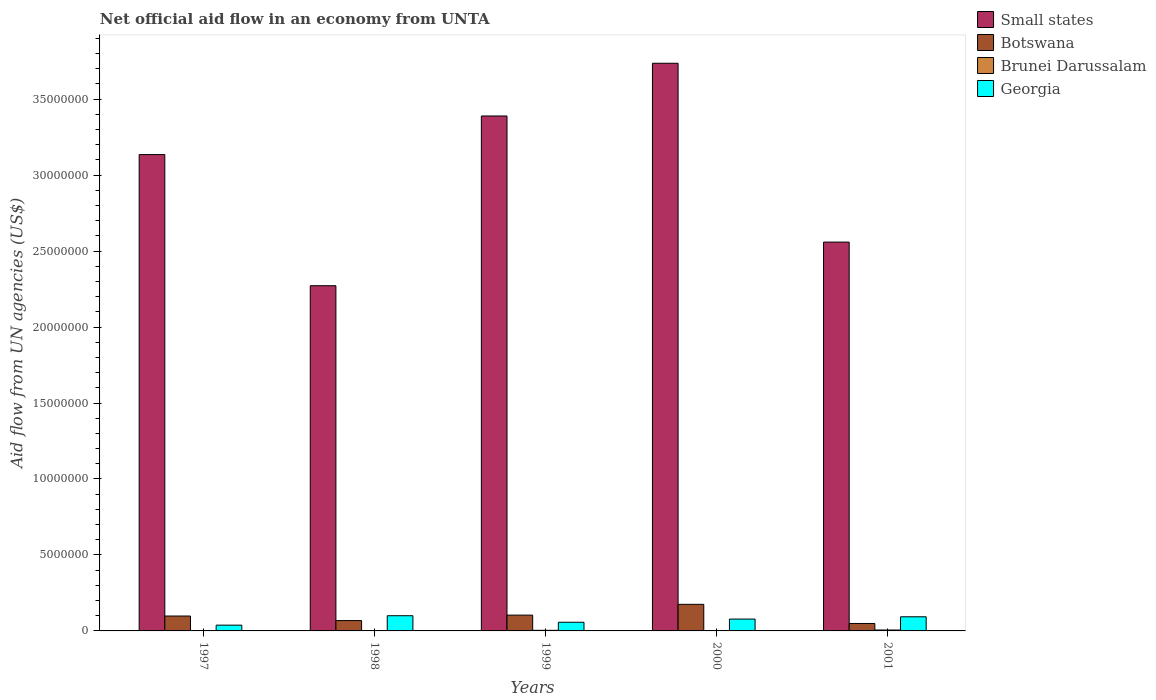Are the number of bars per tick equal to the number of legend labels?
Offer a very short reply. Yes. Are the number of bars on each tick of the X-axis equal?
Your response must be concise. Yes. How many bars are there on the 4th tick from the left?
Your response must be concise. 4. What is the label of the 1st group of bars from the left?
Give a very brief answer. 1997. In how many cases, is the number of bars for a given year not equal to the number of legend labels?
Provide a short and direct response. 0. What is the net official aid flow in Georgia in 1998?
Ensure brevity in your answer.  1.00e+06. Across all years, what is the maximum net official aid flow in Brunei Darussalam?
Ensure brevity in your answer.  6.00e+04. Across all years, what is the minimum net official aid flow in Botswana?
Offer a very short reply. 4.90e+05. In which year was the net official aid flow in Botswana minimum?
Ensure brevity in your answer.  2001. What is the difference between the net official aid flow in Brunei Darussalam in 1997 and that in 2001?
Your answer should be very brief. -4.00e+04. What is the difference between the net official aid flow in Small states in 2000 and the net official aid flow in Botswana in 1997?
Make the answer very short. 3.64e+07. What is the average net official aid flow in Brunei Darussalam per year?
Offer a very short reply. 2.80e+04. In the year 2000, what is the difference between the net official aid flow in Small states and net official aid flow in Botswana?
Provide a short and direct response. 3.56e+07. What is the ratio of the net official aid flow in Small states in 1997 to that in 2000?
Offer a very short reply. 0.84. What is the difference between the highest and the second highest net official aid flow in Small states?
Your answer should be compact. 3.47e+06. What is the difference between the highest and the lowest net official aid flow in Small states?
Your answer should be very brief. 1.46e+07. In how many years, is the net official aid flow in Brunei Darussalam greater than the average net official aid flow in Brunei Darussalam taken over all years?
Provide a short and direct response. 2. Is the sum of the net official aid flow in Botswana in 1999 and 2001 greater than the maximum net official aid flow in Small states across all years?
Ensure brevity in your answer.  No. Is it the case that in every year, the sum of the net official aid flow in Georgia and net official aid flow in Botswana is greater than the sum of net official aid flow in Small states and net official aid flow in Brunei Darussalam?
Your answer should be compact. No. What does the 1st bar from the left in 2000 represents?
Offer a very short reply. Small states. What does the 3rd bar from the right in 1997 represents?
Your response must be concise. Botswana. How many bars are there?
Offer a terse response. 20. Are all the bars in the graph horizontal?
Provide a short and direct response. No. Does the graph contain grids?
Keep it short and to the point. No. Where does the legend appear in the graph?
Keep it short and to the point. Top right. What is the title of the graph?
Offer a terse response. Net official aid flow in an economy from UNTA. What is the label or title of the X-axis?
Offer a terse response. Years. What is the label or title of the Y-axis?
Your answer should be very brief. Aid flow from UN agencies (US$). What is the Aid flow from UN agencies (US$) in Small states in 1997?
Your answer should be compact. 3.14e+07. What is the Aid flow from UN agencies (US$) of Botswana in 1997?
Provide a short and direct response. 9.80e+05. What is the Aid flow from UN agencies (US$) of Brunei Darussalam in 1997?
Give a very brief answer. 2.00e+04. What is the Aid flow from UN agencies (US$) in Small states in 1998?
Provide a succinct answer. 2.27e+07. What is the Aid flow from UN agencies (US$) of Botswana in 1998?
Your answer should be compact. 6.80e+05. What is the Aid flow from UN agencies (US$) of Brunei Darussalam in 1998?
Offer a very short reply. 10000. What is the Aid flow from UN agencies (US$) in Georgia in 1998?
Offer a very short reply. 1.00e+06. What is the Aid flow from UN agencies (US$) in Small states in 1999?
Keep it short and to the point. 3.39e+07. What is the Aid flow from UN agencies (US$) of Botswana in 1999?
Give a very brief answer. 1.04e+06. What is the Aid flow from UN agencies (US$) in Brunei Darussalam in 1999?
Make the answer very short. 4.00e+04. What is the Aid flow from UN agencies (US$) in Georgia in 1999?
Your answer should be very brief. 5.70e+05. What is the Aid flow from UN agencies (US$) of Small states in 2000?
Offer a very short reply. 3.74e+07. What is the Aid flow from UN agencies (US$) of Botswana in 2000?
Provide a short and direct response. 1.75e+06. What is the Aid flow from UN agencies (US$) of Georgia in 2000?
Provide a short and direct response. 7.80e+05. What is the Aid flow from UN agencies (US$) of Small states in 2001?
Your response must be concise. 2.56e+07. What is the Aid flow from UN agencies (US$) in Brunei Darussalam in 2001?
Give a very brief answer. 6.00e+04. What is the Aid flow from UN agencies (US$) of Georgia in 2001?
Your response must be concise. 9.30e+05. Across all years, what is the maximum Aid flow from UN agencies (US$) in Small states?
Ensure brevity in your answer.  3.74e+07. Across all years, what is the maximum Aid flow from UN agencies (US$) in Botswana?
Provide a short and direct response. 1.75e+06. Across all years, what is the maximum Aid flow from UN agencies (US$) of Brunei Darussalam?
Keep it short and to the point. 6.00e+04. Across all years, what is the maximum Aid flow from UN agencies (US$) in Georgia?
Keep it short and to the point. 1.00e+06. Across all years, what is the minimum Aid flow from UN agencies (US$) of Small states?
Offer a terse response. 2.27e+07. Across all years, what is the minimum Aid flow from UN agencies (US$) of Botswana?
Your answer should be compact. 4.90e+05. Across all years, what is the minimum Aid flow from UN agencies (US$) of Georgia?
Your answer should be very brief. 3.80e+05. What is the total Aid flow from UN agencies (US$) in Small states in the graph?
Your response must be concise. 1.51e+08. What is the total Aid flow from UN agencies (US$) in Botswana in the graph?
Give a very brief answer. 4.94e+06. What is the total Aid flow from UN agencies (US$) in Brunei Darussalam in the graph?
Offer a very short reply. 1.40e+05. What is the total Aid flow from UN agencies (US$) in Georgia in the graph?
Provide a short and direct response. 3.66e+06. What is the difference between the Aid flow from UN agencies (US$) of Small states in 1997 and that in 1998?
Make the answer very short. 8.63e+06. What is the difference between the Aid flow from UN agencies (US$) of Botswana in 1997 and that in 1998?
Your answer should be very brief. 3.00e+05. What is the difference between the Aid flow from UN agencies (US$) in Brunei Darussalam in 1997 and that in 1998?
Offer a very short reply. 10000. What is the difference between the Aid flow from UN agencies (US$) of Georgia in 1997 and that in 1998?
Offer a terse response. -6.20e+05. What is the difference between the Aid flow from UN agencies (US$) of Small states in 1997 and that in 1999?
Make the answer very short. -2.54e+06. What is the difference between the Aid flow from UN agencies (US$) in Georgia in 1997 and that in 1999?
Keep it short and to the point. -1.90e+05. What is the difference between the Aid flow from UN agencies (US$) in Small states in 1997 and that in 2000?
Your response must be concise. -6.01e+06. What is the difference between the Aid flow from UN agencies (US$) of Botswana in 1997 and that in 2000?
Ensure brevity in your answer.  -7.70e+05. What is the difference between the Aid flow from UN agencies (US$) of Georgia in 1997 and that in 2000?
Your answer should be very brief. -4.00e+05. What is the difference between the Aid flow from UN agencies (US$) of Small states in 1997 and that in 2001?
Your answer should be compact. 5.76e+06. What is the difference between the Aid flow from UN agencies (US$) in Georgia in 1997 and that in 2001?
Your response must be concise. -5.50e+05. What is the difference between the Aid flow from UN agencies (US$) in Small states in 1998 and that in 1999?
Your response must be concise. -1.12e+07. What is the difference between the Aid flow from UN agencies (US$) in Botswana in 1998 and that in 1999?
Your answer should be very brief. -3.60e+05. What is the difference between the Aid flow from UN agencies (US$) of Georgia in 1998 and that in 1999?
Provide a succinct answer. 4.30e+05. What is the difference between the Aid flow from UN agencies (US$) of Small states in 1998 and that in 2000?
Offer a very short reply. -1.46e+07. What is the difference between the Aid flow from UN agencies (US$) in Botswana in 1998 and that in 2000?
Provide a succinct answer. -1.07e+06. What is the difference between the Aid flow from UN agencies (US$) of Small states in 1998 and that in 2001?
Give a very brief answer. -2.87e+06. What is the difference between the Aid flow from UN agencies (US$) of Botswana in 1998 and that in 2001?
Your answer should be compact. 1.90e+05. What is the difference between the Aid flow from UN agencies (US$) in Brunei Darussalam in 1998 and that in 2001?
Your response must be concise. -5.00e+04. What is the difference between the Aid flow from UN agencies (US$) in Georgia in 1998 and that in 2001?
Your response must be concise. 7.00e+04. What is the difference between the Aid flow from UN agencies (US$) of Small states in 1999 and that in 2000?
Provide a short and direct response. -3.47e+06. What is the difference between the Aid flow from UN agencies (US$) of Botswana in 1999 and that in 2000?
Keep it short and to the point. -7.10e+05. What is the difference between the Aid flow from UN agencies (US$) of Georgia in 1999 and that in 2000?
Your response must be concise. -2.10e+05. What is the difference between the Aid flow from UN agencies (US$) in Small states in 1999 and that in 2001?
Provide a short and direct response. 8.30e+06. What is the difference between the Aid flow from UN agencies (US$) of Brunei Darussalam in 1999 and that in 2001?
Give a very brief answer. -2.00e+04. What is the difference between the Aid flow from UN agencies (US$) in Georgia in 1999 and that in 2001?
Give a very brief answer. -3.60e+05. What is the difference between the Aid flow from UN agencies (US$) of Small states in 2000 and that in 2001?
Ensure brevity in your answer.  1.18e+07. What is the difference between the Aid flow from UN agencies (US$) in Botswana in 2000 and that in 2001?
Offer a very short reply. 1.26e+06. What is the difference between the Aid flow from UN agencies (US$) in Brunei Darussalam in 2000 and that in 2001?
Offer a very short reply. -5.00e+04. What is the difference between the Aid flow from UN agencies (US$) of Small states in 1997 and the Aid flow from UN agencies (US$) of Botswana in 1998?
Your answer should be very brief. 3.07e+07. What is the difference between the Aid flow from UN agencies (US$) of Small states in 1997 and the Aid flow from UN agencies (US$) of Brunei Darussalam in 1998?
Give a very brief answer. 3.13e+07. What is the difference between the Aid flow from UN agencies (US$) in Small states in 1997 and the Aid flow from UN agencies (US$) in Georgia in 1998?
Provide a short and direct response. 3.04e+07. What is the difference between the Aid flow from UN agencies (US$) in Botswana in 1997 and the Aid flow from UN agencies (US$) in Brunei Darussalam in 1998?
Keep it short and to the point. 9.70e+05. What is the difference between the Aid flow from UN agencies (US$) of Brunei Darussalam in 1997 and the Aid flow from UN agencies (US$) of Georgia in 1998?
Your response must be concise. -9.80e+05. What is the difference between the Aid flow from UN agencies (US$) in Small states in 1997 and the Aid flow from UN agencies (US$) in Botswana in 1999?
Your answer should be very brief. 3.03e+07. What is the difference between the Aid flow from UN agencies (US$) in Small states in 1997 and the Aid flow from UN agencies (US$) in Brunei Darussalam in 1999?
Your response must be concise. 3.13e+07. What is the difference between the Aid flow from UN agencies (US$) in Small states in 1997 and the Aid flow from UN agencies (US$) in Georgia in 1999?
Your answer should be compact. 3.08e+07. What is the difference between the Aid flow from UN agencies (US$) in Botswana in 1997 and the Aid flow from UN agencies (US$) in Brunei Darussalam in 1999?
Keep it short and to the point. 9.40e+05. What is the difference between the Aid flow from UN agencies (US$) in Botswana in 1997 and the Aid flow from UN agencies (US$) in Georgia in 1999?
Provide a short and direct response. 4.10e+05. What is the difference between the Aid flow from UN agencies (US$) of Brunei Darussalam in 1997 and the Aid flow from UN agencies (US$) of Georgia in 1999?
Provide a short and direct response. -5.50e+05. What is the difference between the Aid flow from UN agencies (US$) of Small states in 1997 and the Aid flow from UN agencies (US$) of Botswana in 2000?
Provide a succinct answer. 2.96e+07. What is the difference between the Aid flow from UN agencies (US$) of Small states in 1997 and the Aid flow from UN agencies (US$) of Brunei Darussalam in 2000?
Your answer should be compact. 3.13e+07. What is the difference between the Aid flow from UN agencies (US$) in Small states in 1997 and the Aid flow from UN agencies (US$) in Georgia in 2000?
Your answer should be very brief. 3.06e+07. What is the difference between the Aid flow from UN agencies (US$) in Botswana in 1997 and the Aid flow from UN agencies (US$) in Brunei Darussalam in 2000?
Your answer should be very brief. 9.70e+05. What is the difference between the Aid flow from UN agencies (US$) in Brunei Darussalam in 1997 and the Aid flow from UN agencies (US$) in Georgia in 2000?
Offer a very short reply. -7.60e+05. What is the difference between the Aid flow from UN agencies (US$) in Small states in 1997 and the Aid flow from UN agencies (US$) in Botswana in 2001?
Provide a short and direct response. 3.09e+07. What is the difference between the Aid flow from UN agencies (US$) in Small states in 1997 and the Aid flow from UN agencies (US$) in Brunei Darussalam in 2001?
Provide a short and direct response. 3.13e+07. What is the difference between the Aid flow from UN agencies (US$) in Small states in 1997 and the Aid flow from UN agencies (US$) in Georgia in 2001?
Provide a succinct answer. 3.04e+07. What is the difference between the Aid flow from UN agencies (US$) of Botswana in 1997 and the Aid flow from UN agencies (US$) of Brunei Darussalam in 2001?
Make the answer very short. 9.20e+05. What is the difference between the Aid flow from UN agencies (US$) in Botswana in 1997 and the Aid flow from UN agencies (US$) in Georgia in 2001?
Keep it short and to the point. 5.00e+04. What is the difference between the Aid flow from UN agencies (US$) of Brunei Darussalam in 1997 and the Aid flow from UN agencies (US$) of Georgia in 2001?
Ensure brevity in your answer.  -9.10e+05. What is the difference between the Aid flow from UN agencies (US$) in Small states in 1998 and the Aid flow from UN agencies (US$) in Botswana in 1999?
Keep it short and to the point. 2.17e+07. What is the difference between the Aid flow from UN agencies (US$) of Small states in 1998 and the Aid flow from UN agencies (US$) of Brunei Darussalam in 1999?
Make the answer very short. 2.27e+07. What is the difference between the Aid flow from UN agencies (US$) of Small states in 1998 and the Aid flow from UN agencies (US$) of Georgia in 1999?
Your answer should be very brief. 2.22e+07. What is the difference between the Aid flow from UN agencies (US$) in Botswana in 1998 and the Aid flow from UN agencies (US$) in Brunei Darussalam in 1999?
Provide a succinct answer. 6.40e+05. What is the difference between the Aid flow from UN agencies (US$) of Botswana in 1998 and the Aid flow from UN agencies (US$) of Georgia in 1999?
Give a very brief answer. 1.10e+05. What is the difference between the Aid flow from UN agencies (US$) in Brunei Darussalam in 1998 and the Aid flow from UN agencies (US$) in Georgia in 1999?
Make the answer very short. -5.60e+05. What is the difference between the Aid flow from UN agencies (US$) in Small states in 1998 and the Aid flow from UN agencies (US$) in Botswana in 2000?
Give a very brief answer. 2.10e+07. What is the difference between the Aid flow from UN agencies (US$) of Small states in 1998 and the Aid flow from UN agencies (US$) of Brunei Darussalam in 2000?
Offer a terse response. 2.27e+07. What is the difference between the Aid flow from UN agencies (US$) of Small states in 1998 and the Aid flow from UN agencies (US$) of Georgia in 2000?
Keep it short and to the point. 2.19e+07. What is the difference between the Aid flow from UN agencies (US$) in Botswana in 1998 and the Aid flow from UN agencies (US$) in Brunei Darussalam in 2000?
Give a very brief answer. 6.70e+05. What is the difference between the Aid flow from UN agencies (US$) in Botswana in 1998 and the Aid flow from UN agencies (US$) in Georgia in 2000?
Keep it short and to the point. -1.00e+05. What is the difference between the Aid flow from UN agencies (US$) of Brunei Darussalam in 1998 and the Aid flow from UN agencies (US$) of Georgia in 2000?
Make the answer very short. -7.70e+05. What is the difference between the Aid flow from UN agencies (US$) of Small states in 1998 and the Aid flow from UN agencies (US$) of Botswana in 2001?
Ensure brevity in your answer.  2.22e+07. What is the difference between the Aid flow from UN agencies (US$) in Small states in 1998 and the Aid flow from UN agencies (US$) in Brunei Darussalam in 2001?
Provide a short and direct response. 2.27e+07. What is the difference between the Aid flow from UN agencies (US$) in Small states in 1998 and the Aid flow from UN agencies (US$) in Georgia in 2001?
Your response must be concise. 2.18e+07. What is the difference between the Aid flow from UN agencies (US$) in Botswana in 1998 and the Aid flow from UN agencies (US$) in Brunei Darussalam in 2001?
Keep it short and to the point. 6.20e+05. What is the difference between the Aid flow from UN agencies (US$) of Botswana in 1998 and the Aid flow from UN agencies (US$) of Georgia in 2001?
Make the answer very short. -2.50e+05. What is the difference between the Aid flow from UN agencies (US$) in Brunei Darussalam in 1998 and the Aid flow from UN agencies (US$) in Georgia in 2001?
Keep it short and to the point. -9.20e+05. What is the difference between the Aid flow from UN agencies (US$) in Small states in 1999 and the Aid flow from UN agencies (US$) in Botswana in 2000?
Ensure brevity in your answer.  3.21e+07. What is the difference between the Aid flow from UN agencies (US$) of Small states in 1999 and the Aid flow from UN agencies (US$) of Brunei Darussalam in 2000?
Offer a very short reply. 3.39e+07. What is the difference between the Aid flow from UN agencies (US$) in Small states in 1999 and the Aid flow from UN agencies (US$) in Georgia in 2000?
Offer a terse response. 3.31e+07. What is the difference between the Aid flow from UN agencies (US$) in Botswana in 1999 and the Aid flow from UN agencies (US$) in Brunei Darussalam in 2000?
Keep it short and to the point. 1.03e+06. What is the difference between the Aid flow from UN agencies (US$) of Botswana in 1999 and the Aid flow from UN agencies (US$) of Georgia in 2000?
Your response must be concise. 2.60e+05. What is the difference between the Aid flow from UN agencies (US$) in Brunei Darussalam in 1999 and the Aid flow from UN agencies (US$) in Georgia in 2000?
Your answer should be very brief. -7.40e+05. What is the difference between the Aid flow from UN agencies (US$) in Small states in 1999 and the Aid flow from UN agencies (US$) in Botswana in 2001?
Your answer should be very brief. 3.34e+07. What is the difference between the Aid flow from UN agencies (US$) in Small states in 1999 and the Aid flow from UN agencies (US$) in Brunei Darussalam in 2001?
Your answer should be very brief. 3.38e+07. What is the difference between the Aid flow from UN agencies (US$) of Small states in 1999 and the Aid flow from UN agencies (US$) of Georgia in 2001?
Ensure brevity in your answer.  3.30e+07. What is the difference between the Aid flow from UN agencies (US$) in Botswana in 1999 and the Aid flow from UN agencies (US$) in Brunei Darussalam in 2001?
Ensure brevity in your answer.  9.80e+05. What is the difference between the Aid flow from UN agencies (US$) in Botswana in 1999 and the Aid flow from UN agencies (US$) in Georgia in 2001?
Your response must be concise. 1.10e+05. What is the difference between the Aid flow from UN agencies (US$) of Brunei Darussalam in 1999 and the Aid flow from UN agencies (US$) of Georgia in 2001?
Give a very brief answer. -8.90e+05. What is the difference between the Aid flow from UN agencies (US$) of Small states in 2000 and the Aid flow from UN agencies (US$) of Botswana in 2001?
Make the answer very short. 3.69e+07. What is the difference between the Aid flow from UN agencies (US$) in Small states in 2000 and the Aid flow from UN agencies (US$) in Brunei Darussalam in 2001?
Provide a succinct answer. 3.73e+07. What is the difference between the Aid flow from UN agencies (US$) of Small states in 2000 and the Aid flow from UN agencies (US$) of Georgia in 2001?
Your answer should be compact. 3.64e+07. What is the difference between the Aid flow from UN agencies (US$) of Botswana in 2000 and the Aid flow from UN agencies (US$) of Brunei Darussalam in 2001?
Offer a terse response. 1.69e+06. What is the difference between the Aid flow from UN agencies (US$) of Botswana in 2000 and the Aid flow from UN agencies (US$) of Georgia in 2001?
Keep it short and to the point. 8.20e+05. What is the difference between the Aid flow from UN agencies (US$) of Brunei Darussalam in 2000 and the Aid flow from UN agencies (US$) of Georgia in 2001?
Ensure brevity in your answer.  -9.20e+05. What is the average Aid flow from UN agencies (US$) of Small states per year?
Give a very brief answer. 3.02e+07. What is the average Aid flow from UN agencies (US$) of Botswana per year?
Offer a terse response. 9.88e+05. What is the average Aid flow from UN agencies (US$) of Brunei Darussalam per year?
Your answer should be very brief. 2.80e+04. What is the average Aid flow from UN agencies (US$) in Georgia per year?
Your answer should be very brief. 7.32e+05. In the year 1997, what is the difference between the Aid flow from UN agencies (US$) of Small states and Aid flow from UN agencies (US$) of Botswana?
Your answer should be compact. 3.04e+07. In the year 1997, what is the difference between the Aid flow from UN agencies (US$) of Small states and Aid flow from UN agencies (US$) of Brunei Darussalam?
Your answer should be very brief. 3.13e+07. In the year 1997, what is the difference between the Aid flow from UN agencies (US$) of Small states and Aid flow from UN agencies (US$) of Georgia?
Provide a short and direct response. 3.10e+07. In the year 1997, what is the difference between the Aid flow from UN agencies (US$) of Botswana and Aid flow from UN agencies (US$) of Brunei Darussalam?
Ensure brevity in your answer.  9.60e+05. In the year 1997, what is the difference between the Aid flow from UN agencies (US$) in Botswana and Aid flow from UN agencies (US$) in Georgia?
Your answer should be very brief. 6.00e+05. In the year 1997, what is the difference between the Aid flow from UN agencies (US$) in Brunei Darussalam and Aid flow from UN agencies (US$) in Georgia?
Provide a succinct answer. -3.60e+05. In the year 1998, what is the difference between the Aid flow from UN agencies (US$) of Small states and Aid flow from UN agencies (US$) of Botswana?
Your answer should be compact. 2.20e+07. In the year 1998, what is the difference between the Aid flow from UN agencies (US$) in Small states and Aid flow from UN agencies (US$) in Brunei Darussalam?
Offer a very short reply. 2.27e+07. In the year 1998, what is the difference between the Aid flow from UN agencies (US$) in Small states and Aid flow from UN agencies (US$) in Georgia?
Make the answer very short. 2.17e+07. In the year 1998, what is the difference between the Aid flow from UN agencies (US$) of Botswana and Aid flow from UN agencies (US$) of Brunei Darussalam?
Offer a terse response. 6.70e+05. In the year 1998, what is the difference between the Aid flow from UN agencies (US$) of Botswana and Aid flow from UN agencies (US$) of Georgia?
Provide a succinct answer. -3.20e+05. In the year 1998, what is the difference between the Aid flow from UN agencies (US$) of Brunei Darussalam and Aid flow from UN agencies (US$) of Georgia?
Provide a short and direct response. -9.90e+05. In the year 1999, what is the difference between the Aid flow from UN agencies (US$) in Small states and Aid flow from UN agencies (US$) in Botswana?
Provide a short and direct response. 3.28e+07. In the year 1999, what is the difference between the Aid flow from UN agencies (US$) in Small states and Aid flow from UN agencies (US$) in Brunei Darussalam?
Give a very brief answer. 3.38e+07. In the year 1999, what is the difference between the Aid flow from UN agencies (US$) in Small states and Aid flow from UN agencies (US$) in Georgia?
Make the answer very short. 3.33e+07. In the year 1999, what is the difference between the Aid flow from UN agencies (US$) in Brunei Darussalam and Aid flow from UN agencies (US$) in Georgia?
Offer a very short reply. -5.30e+05. In the year 2000, what is the difference between the Aid flow from UN agencies (US$) of Small states and Aid flow from UN agencies (US$) of Botswana?
Provide a short and direct response. 3.56e+07. In the year 2000, what is the difference between the Aid flow from UN agencies (US$) of Small states and Aid flow from UN agencies (US$) of Brunei Darussalam?
Your answer should be very brief. 3.74e+07. In the year 2000, what is the difference between the Aid flow from UN agencies (US$) of Small states and Aid flow from UN agencies (US$) of Georgia?
Make the answer very short. 3.66e+07. In the year 2000, what is the difference between the Aid flow from UN agencies (US$) in Botswana and Aid flow from UN agencies (US$) in Brunei Darussalam?
Make the answer very short. 1.74e+06. In the year 2000, what is the difference between the Aid flow from UN agencies (US$) in Botswana and Aid flow from UN agencies (US$) in Georgia?
Keep it short and to the point. 9.70e+05. In the year 2000, what is the difference between the Aid flow from UN agencies (US$) in Brunei Darussalam and Aid flow from UN agencies (US$) in Georgia?
Give a very brief answer. -7.70e+05. In the year 2001, what is the difference between the Aid flow from UN agencies (US$) in Small states and Aid flow from UN agencies (US$) in Botswana?
Give a very brief answer. 2.51e+07. In the year 2001, what is the difference between the Aid flow from UN agencies (US$) in Small states and Aid flow from UN agencies (US$) in Brunei Darussalam?
Give a very brief answer. 2.55e+07. In the year 2001, what is the difference between the Aid flow from UN agencies (US$) in Small states and Aid flow from UN agencies (US$) in Georgia?
Keep it short and to the point. 2.47e+07. In the year 2001, what is the difference between the Aid flow from UN agencies (US$) of Botswana and Aid flow from UN agencies (US$) of Georgia?
Give a very brief answer. -4.40e+05. In the year 2001, what is the difference between the Aid flow from UN agencies (US$) in Brunei Darussalam and Aid flow from UN agencies (US$) in Georgia?
Your answer should be very brief. -8.70e+05. What is the ratio of the Aid flow from UN agencies (US$) in Small states in 1997 to that in 1998?
Offer a very short reply. 1.38. What is the ratio of the Aid flow from UN agencies (US$) in Botswana in 1997 to that in 1998?
Make the answer very short. 1.44. What is the ratio of the Aid flow from UN agencies (US$) in Brunei Darussalam in 1997 to that in 1998?
Make the answer very short. 2. What is the ratio of the Aid flow from UN agencies (US$) of Georgia in 1997 to that in 1998?
Keep it short and to the point. 0.38. What is the ratio of the Aid flow from UN agencies (US$) of Small states in 1997 to that in 1999?
Give a very brief answer. 0.93. What is the ratio of the Aid flow from UN agencies (US$) of Botswana in 1997 to that in 1999?
Your answer should be very brief. 0.94. What is the ratio of the Aid flow from UN agencies (US$) of Brunei Darussalam in 1997 to that in 1999?
Provide a short and direct response. 0.5. What is the ratio of the Aid flow from UN agencies (US$) in Georgia in 1997 to that in 1999?
Your answer should be compact. 0.67. What is the ratio of the Aid flow from UN agencies (US$) of Small states in 1997 to that in 2000?
Your answer should be very brief. 0.84. What is the ratio of the Aid flow from UN agencies (US$) of Botswana in 1997 to that in 2000?
Ensure brevity in your answer.  0.56. What is the ratio of the Aid flow from UN agencies (US$) of Georgia in 1997 to that in 2000?
Keep it short and to the point. 0.49. What is the ratio of the Aid flow from UN agencies (US$) in Small states in 1997 to that in 2001?
Make the answer very short. 1.23. What is the ratio of the Aid flow from UN agencies (US$) in Brunei Darussalam in 1997 to that in 2001?
Provide a succinct answer. 0.33. What is the ratio of the Aid flow from UN agencies (US$) in Georgia in 1997 to that in 2001?
Offer a terse response. 0.41. What is the ratio of the Aid flow from UN agencies (US$) of Small states in 1998 to that in 1999?
Your response must be concise. 0.67. What is the ratio of the Aid flow from UN agencies (US$) in Botswana in 1998 to that in 1999?
Provide a succinct answer. 0.65. What is the ratio of the Aid flow from UN agencies (US$) in Georgia in 1998 to that in 1999?
Your response must be concise. 1.75. What is the ratio of the Aid flow from UN agencies (US$) in Small states in 1998 to that in 2000?
Your answer should be compact. 0.61. What is the ratio of the Aid flow from UN agencies (US$) of Botswana in 1998 to that in 2000?
Your answer should be compact. 0.39. What is the ratio of the Aid flow from UN agencies (US$) of Georgia in 1998 to that in 2000?
Provide a succinct answer. 1.28. What is the ratio of the Aid flow from UN agencies (US$) in Small states in 1998 to that in 2001?
Your answer should be very brief. 0.89. What is the ratio of the Aid flow from UN agencies (US$) of Botswana in 1998 to that in 2001?
Offer a very short reply. 1.39. What is the ratio of the Aid flow from UN agencies (US$) in Georgia in 1998 to that in 2001?
Make the answer very short. 1.08. What is the ratio of the Aid flow from UN agencies (US$) of Small states in 1999 to that in 2000?
Provide a short and direct response. 0.91. What is the ratio of the Aid flow from UN agencies (US$) in Botswana in 1999 to that in 2000?
Provide a succinct answer. 0.59. What is the ratio of the Aid flow from UN agencies (US$) in Georgia in 1999 to that in 2000?
Offer a very short reply. 0.73. What is the ratio of the Aid flow from UN agencies (US$) of Small states in 1999 to that in 2001?
Your answer should be compact. 1.32. What is the ratio of the Aid flow from UN agencies (US$) of Botswana in 1999 to that in 2001?
Provide a succinct answer. 2.12. What is the ratio of the Aid flow from UN agencies (US$) of Brunei Darussalam in 1999 to that in 2001?
Your response must be concise. 0.67. What is the ratio of the Aid flow from UN agencies (US$) of Georgia in 1999 to that in 2001?
Ensure brevity in your answer.  0.61. What is the ratio of the Aid flow from UN agencies (US$) in Small states in 2000 to that in 2001?
Your response must be concise. 1.46. What is the ratio of the Aid flow from UN agencies (US$) of Botswana in 2000 to that in 2001?
Your answer should be compact. 3.57. What is the ratio of the Aid flow from UN agencies (US$) of Brunei Darussalam in 2000 to that in 2001?
Ensure brevity in your answer.  0.17. What is the ratio of the Aid flow from UN agencies (US$) in Georgia in 2000 to that in 2001?
Provide a short and direct response. 0.84. What is the difference between the highest and the second highest Aid flow from UN agencies (US$) of Small states?
Ensure brevity in your answer.  3.47e+06. What is the difference between the highest and the second highest Aid flow from UN agencies (US$) of Botswana?
Give a very brief answer. 7.10e+05. What is the difference between the highest and the second highest Aid flow from UN agencies (US$) in Georgia?
Offer a very short reply. 7.00e+04. What is the difference between the highest and the lowest Aid flow from UN agencies (US$) of Small states?
Offer a terse response. 1.46e+07. What is the difference between the highest and the lowest Aid flow from UN agencies (US$) of Botswana?
Your response must be concise. 1.26e+06. What is the difference between the highest and the lowest Aid flow from UN agencies (US$) in Georgia?
Make the answer very short. 6.20e+05. 